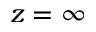Convert formula to latex. <formula><loc_0><loc_0><loc_500><loc_500>z = \infty</formula> 